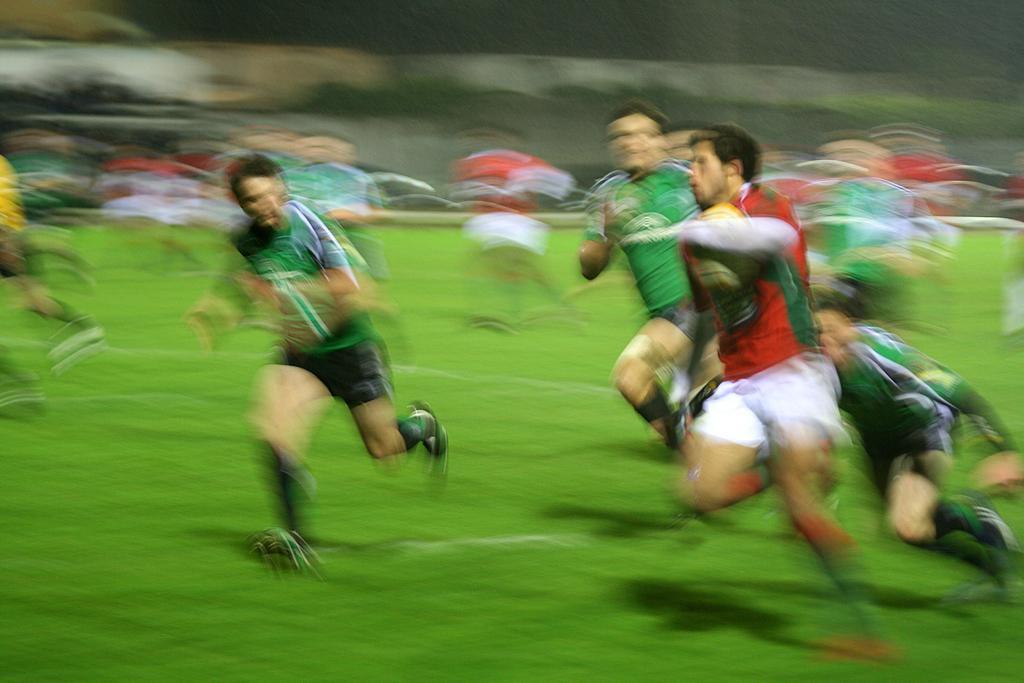In one or two sentences, can you explain what this image depicts? In the center of the image there are people running. At the bottom of the image there is grass. 